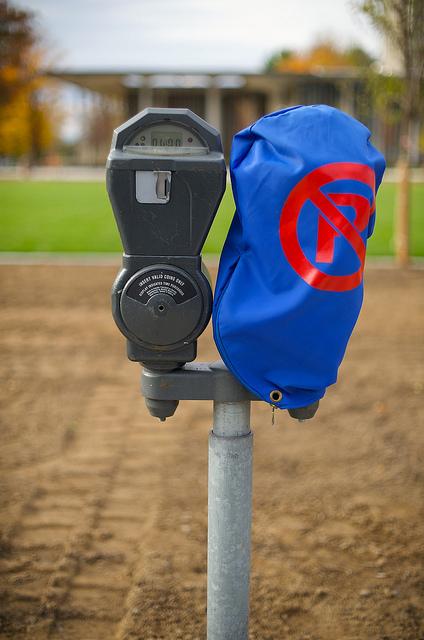Is the parking lot paved?
Quick response, please. No. What picture is on the parking meter?
Keep it brief. No parking. How many parking spots are along this curb?
Give a very brief answer. 1. What type of coin do most parking slots use?
Answer briefly. Quarters. Why is one parking meter covered?
Give a very brief answer. No parking. 